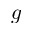<formula> <loc_0><loc_0><loc_500><loc_500>g</formula> 